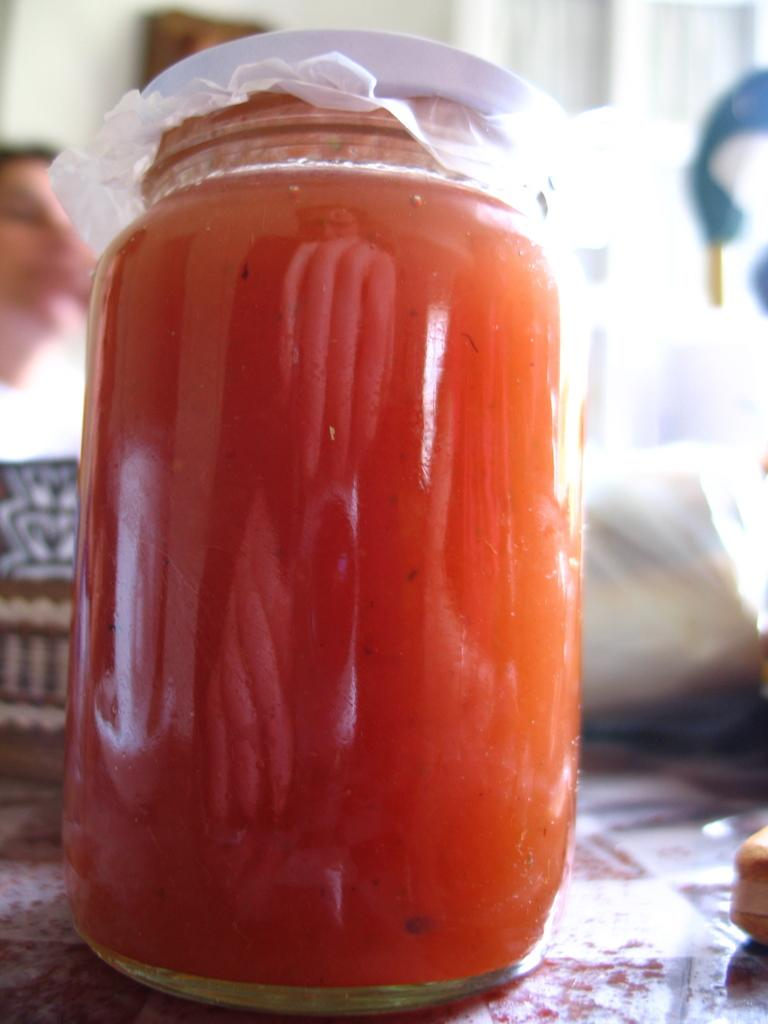What is inside the jar that is visible in the image? There is food in the jar that is visible in the image. How is the food in the jar being protected or covered? The food is covered with a cloth. What can be seen in the background of the image? The background of the image is blurred. What is visible at the bottom of the image? There is a surface visible at the bottom of the image. What else is present in the image besides the jar and food? There are objects in the image. Can you identify a person in the image? Yes, there is a person in the image. What type of shoes is the person wearing in the image? There is no information about shoes in the image, as the focus is on the jar and food. 